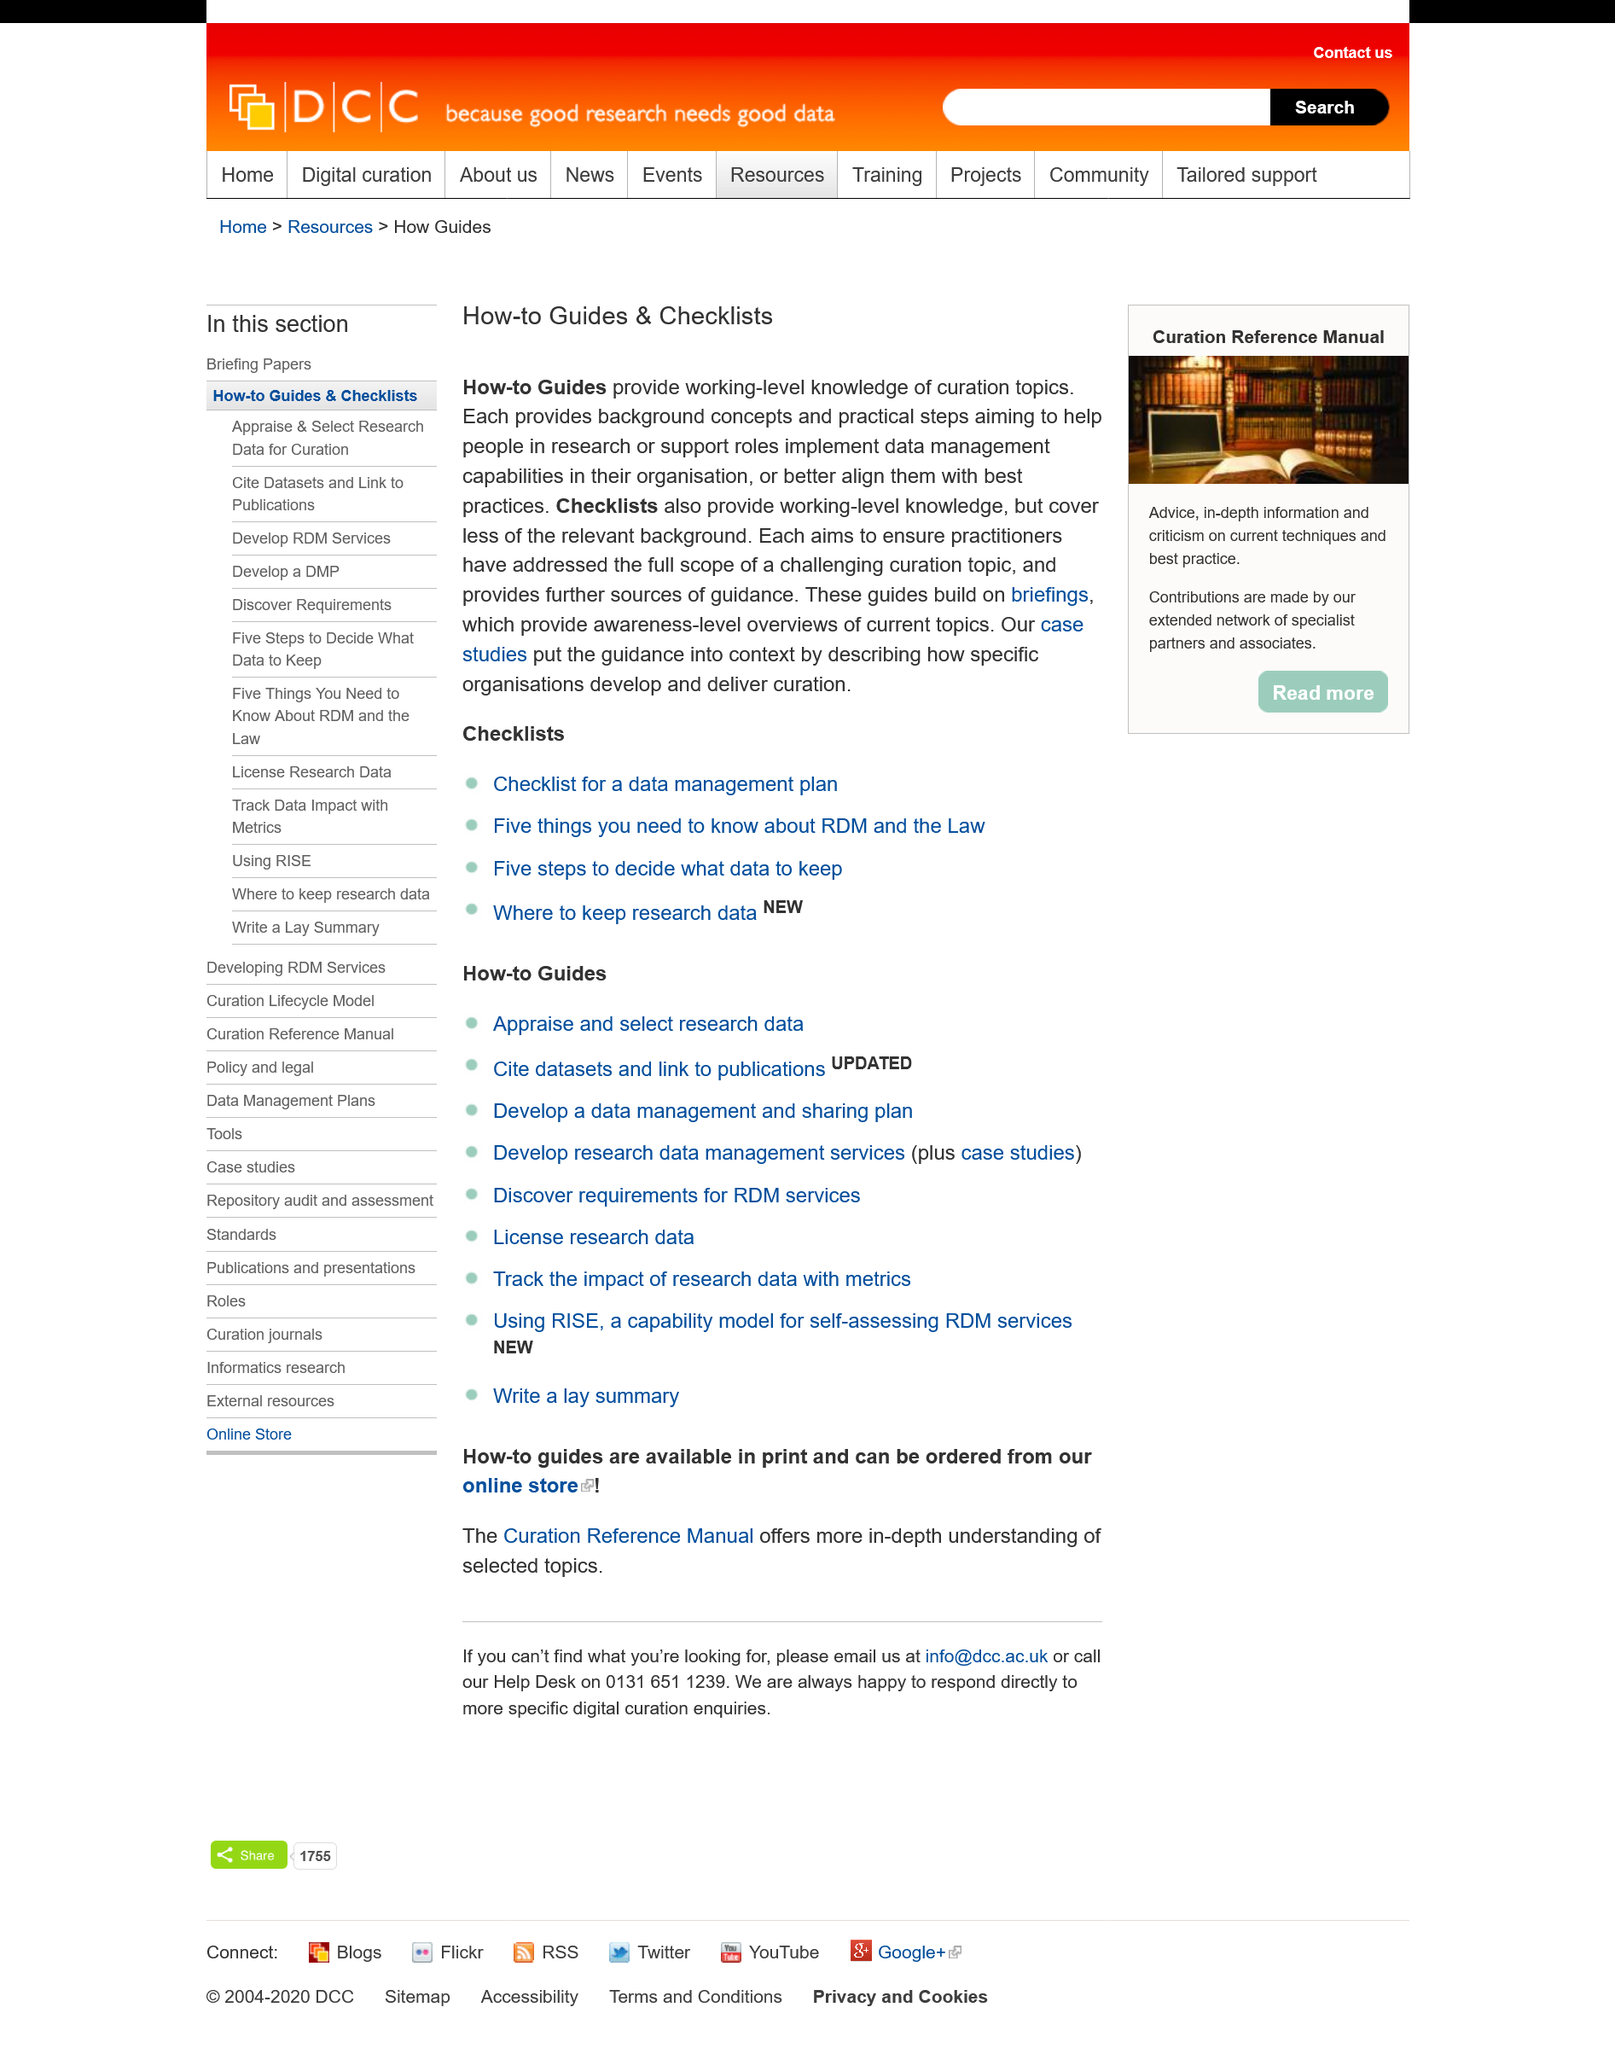List a handful of essential elements in this visual. This article provides comprehensive coverage of both How-to Guides and Checklists, providing readers with a complete understanding of the subject matter at hand. How-to guides and checklists are constructed by building upon briefings that offer awareness-level summaries of current topics. Checklists do not provide as much background information as How-to Guides. 